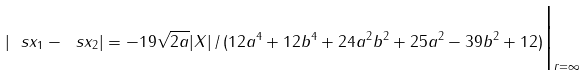<formula> <loc_0><loc_0><loc_500><loc_500>| \ s x _ { 1 } - \ s x _ { 2 } | = - 1 9 \sqrt { 2 a } | X | \, / \, ( 1 2 a ^ { 4 } + 1 2 b ^ { 4 } + 2 4 a ^ { 2 } b ^ { 2 } + 2 5 a ^ { 2 } - 3 9 b ^ { 2 } + 1 2 ) \Big | _ { r = \infty }</formula> 